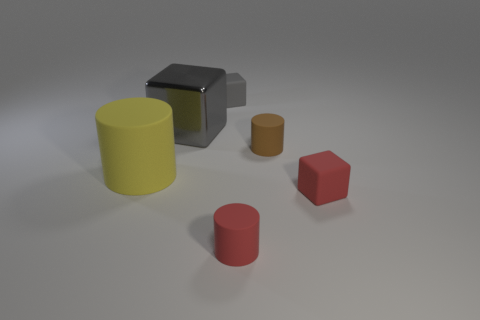Is the number of tiny brown rubber objects less than the number of tiny cylinders? Yes, there are fewer tiny brown rubber objects, which we can identify as the two smaller objects in the middle, as compared to the cylinders, which are represented by the large yellow and small red objects. 